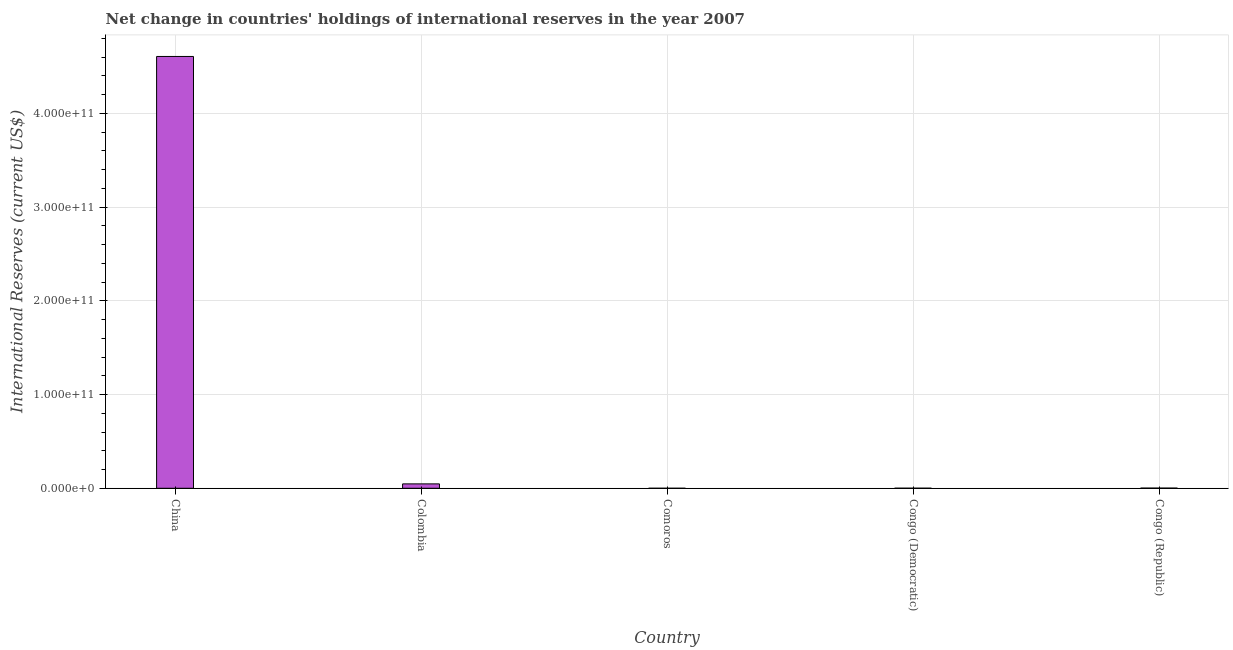Does the graph contain grids?
Provide a succinct answer. Yes. What is the title of the graph?
Give a very brief answer. Net change in countries' holdings of international reserves in the year 2007. What is the label or title of the Y-axis?
Your answer should be compact. International Reserves (current US$). What is the reserves and related items in Comoros?
Your response must be concise. 7.63e+06. Across all countries, what is the maximum reserves and related items?
Give a very brief answer. 4.61e+11. Across all countries, what is the minimum reserves and related items?
Offer a very short reply. 7.63e+06. In which country was the reserves and related items minimum?
Offer a very short reply. Comoros. What is the sum of the reserves and related items?
Provide a short and direct response. 4.66e+11. What is the difference between the reserves and related items in China and Congo (Republic)?
Keep it short and to the point. 4.60e+11. What is the average reserves and related items per country?
Ensure brevity in your answer.  9.31e+1. What is the median reserves and related items?
Make the answer very short. 1.96e+08. What is the ratio of the reserves and related items in Colombia to that in Comoros?
Ensure brevity in your answer.  614.78. Is the reserves and related items in China less than that in Comoros?
Give a very brief answer. No. What is the difference between the highest and the second highest reserves and related items?
Ensure brevity in your answer.  4.56e+11. What is the difference between the highest and the lowest reserves and related items?
Provide a succinct answer. 4.61e+11. How many bars are there?
Give a very brief answer. 5. How many countries are there in the graph?
Your response must be concise. 5. What is the difference between two consecutive major ticks on the Y-axis?
Offer a very short reply. 1.00e+11. What is the International Reserves (current US$) of China?
Your answer should be compact. 4.61e+11. What is the International Reserves (current US$) in Colombia?
Keep it short and to the point. 4.69e+09. What is the International Reserves (current US$) of Comoros?
Your response must be concise. 7.63e+06. What is the International Reserves (current US$) in Congo (Democratic)?
Ensure brevity in your answer.  6.96e+07. What is the International Reserves (current US$) of Congo (Republic)?
Your answer should be very brief. 1.96e+08. What is the difference between the International Reserves (current US$) in China and Colombia?
Offer a terse response. 4.56e+11. What is the difference between the International Reserves (current US$) in China and Comoros?
Give a very brief answer. 4.61e+11. What is the difference between the International Reserves (current US$) in China and Congo (Democratic)?
Give a very brief answer. 4.61e+11. What is the difference between the International Reserves (current US$) in China and Congo (Republic)?
Your answer should be compact. 4.60e+11. What is the difference between the International Reserves (current US$) in Colombia and Comoros?
Make the answer very short. 4.68e+09. What is the difference between the International Reserves (current US$) in Colombia and Congo (Democratic)?
Ensure brevity in your answer.  4.62e+09. What is the difference between the International Reserves (current US$) in Colombia and Congo (Republic)?
Offer a very short reply. 4.49e+09. What is the difference between the International Reserves (current US$) in Comoros and Congo (Democratic)?
Provide a short and direct response. -6.20e+07. What is the difference between the International Reserves (current US$) in Comoros and Congo (Republic)?
Keep it short and to the point. -1.89e+08. What is the difference between the International Reserves (current US$) in Congo (Democratic) and Congo (Republic)?
Provide a short and direct response. -1.27e+08. What is the ratio of the International Reserves (current US$) in China to that in Colombia?
Your response must be concise. 98.27. What is the ratio of the International Reserves (current US$) in China to that in Comoros?
Your answer should be compact. 6.04e+04. What is the ratio of the International Reserves (current US$) in China to that in Congo (Democratic)?
Give a very brief answer. 6617.11. What is the ratio of the International Reserves (current US$) in China to that in Congo (Republic)?
Ensure brevity in your answer.  2345.78. What is the ratio of the International Reserves (current US$) in Colombia to that in Comoros?
Give a very brief answer. 614.78. What is the ratio of the International Reserves (current US$) in Colombia to that in Congo (Democratic)?
Provide a short and direct response. 67.34. What is the ratio of the International Reserves (current US$) in Colombia to that in Congo (Republic)?
Your answer should be compact. 23.87. What is the ratio of the International Reserves (current US$) in Comoros to that in Congo (Democratic)?
Offer a very short reply. 0.11. What is the ratio of the International Reserves (current US$) in Comoros to that in Congo (Republic)?
Make the answer very short. 0.04. What is the ratio of the International Reserves (current US$) in Congo (Democratic) to that in Congo (Republic)?
Give a very brief answer. 0.35. 